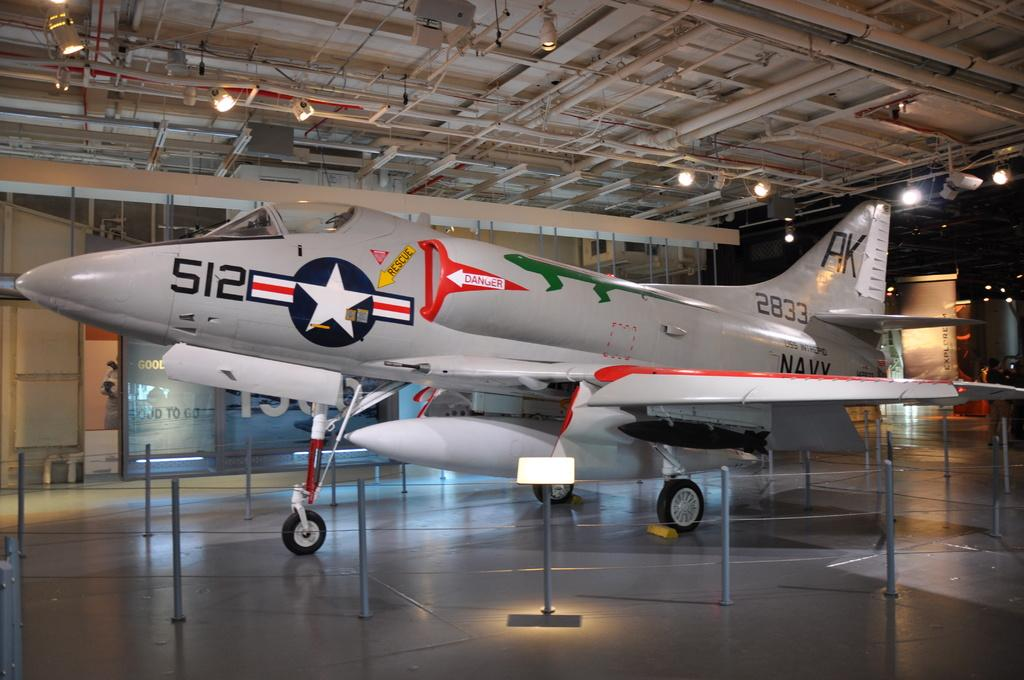<image>
Present a compact description of the photo's key features. A military Jet plane with the number 512 on the fuselage 